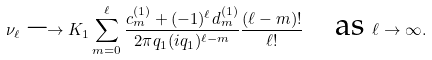<formula> <loc_0><loc_0><loc_500><loc_500>\nu _ { \ell } \longrightarrow K _ { 1 } \sum _ { m = 0 } ^ { \ell } \frac { c ^ { ( 1 ) } _ { m } + ( - 1 ) ^ { \ell } d ^ { ( 1 ) } _ { m } } { 2 \pi q _ { 1 } ( i q _ { 1 } ) ^ { \ell - m } } \frac { ( \ell - m ) ! } { \ell ! } \quad \text {as } \ell \to \infty .</formula> 